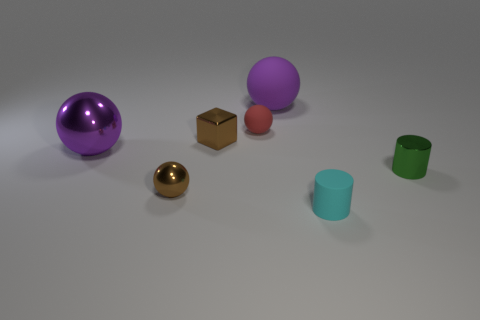Subtract all gray cylinders. How many purple spheres are left? 2 Subtract all small brown metallic spheres. How many spheres are left? 3 Subtract 1 balls. How many balls are left? 3 Add 2 tiny red rubber things. How many objects exist? 9 Subtract all red spheres. How many spheres are left? 3 Subtract all cubes. How many objects are left? 6 Subtract 0 purple cylinders. How many objects are left? 7 Subtract all cyan spheres. Subtract all blue cubes. How many spheres are left? 4 Subtract all rubber objects. Subtract all small red shiny things. How many objects are left? 4 Add 6 small brown metallic objects. How many small brown metallic objects are left? 8 